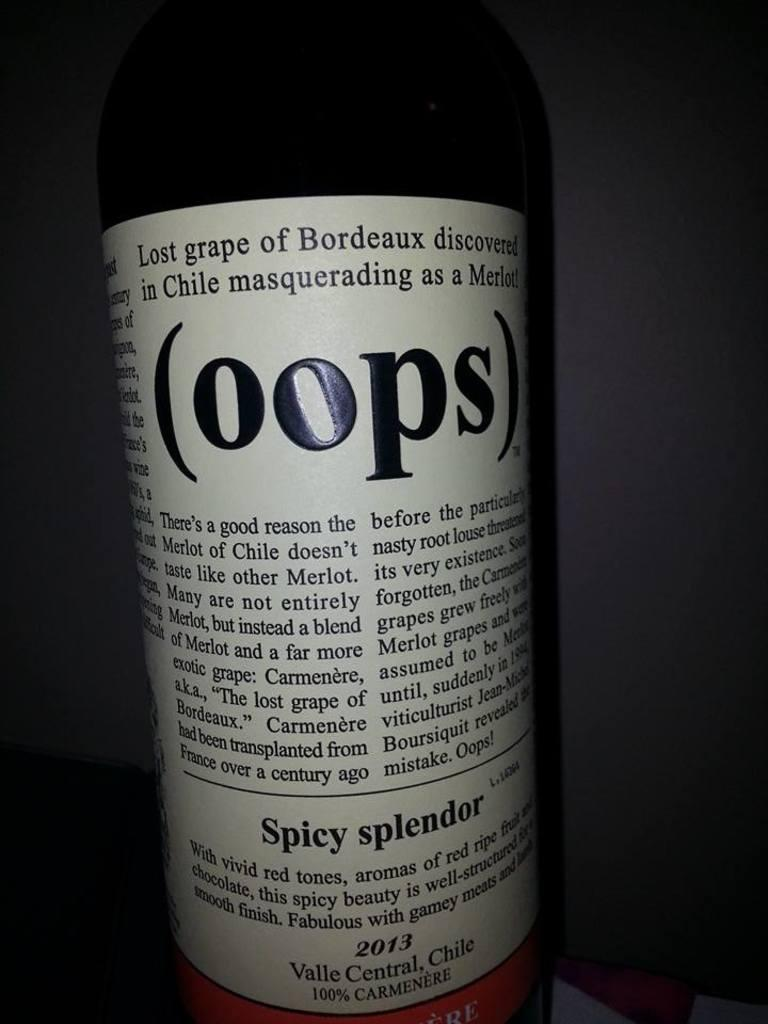<image>
Write a terse but informative summary of the picture. Wine bottle with a label that says OOPS on it. 